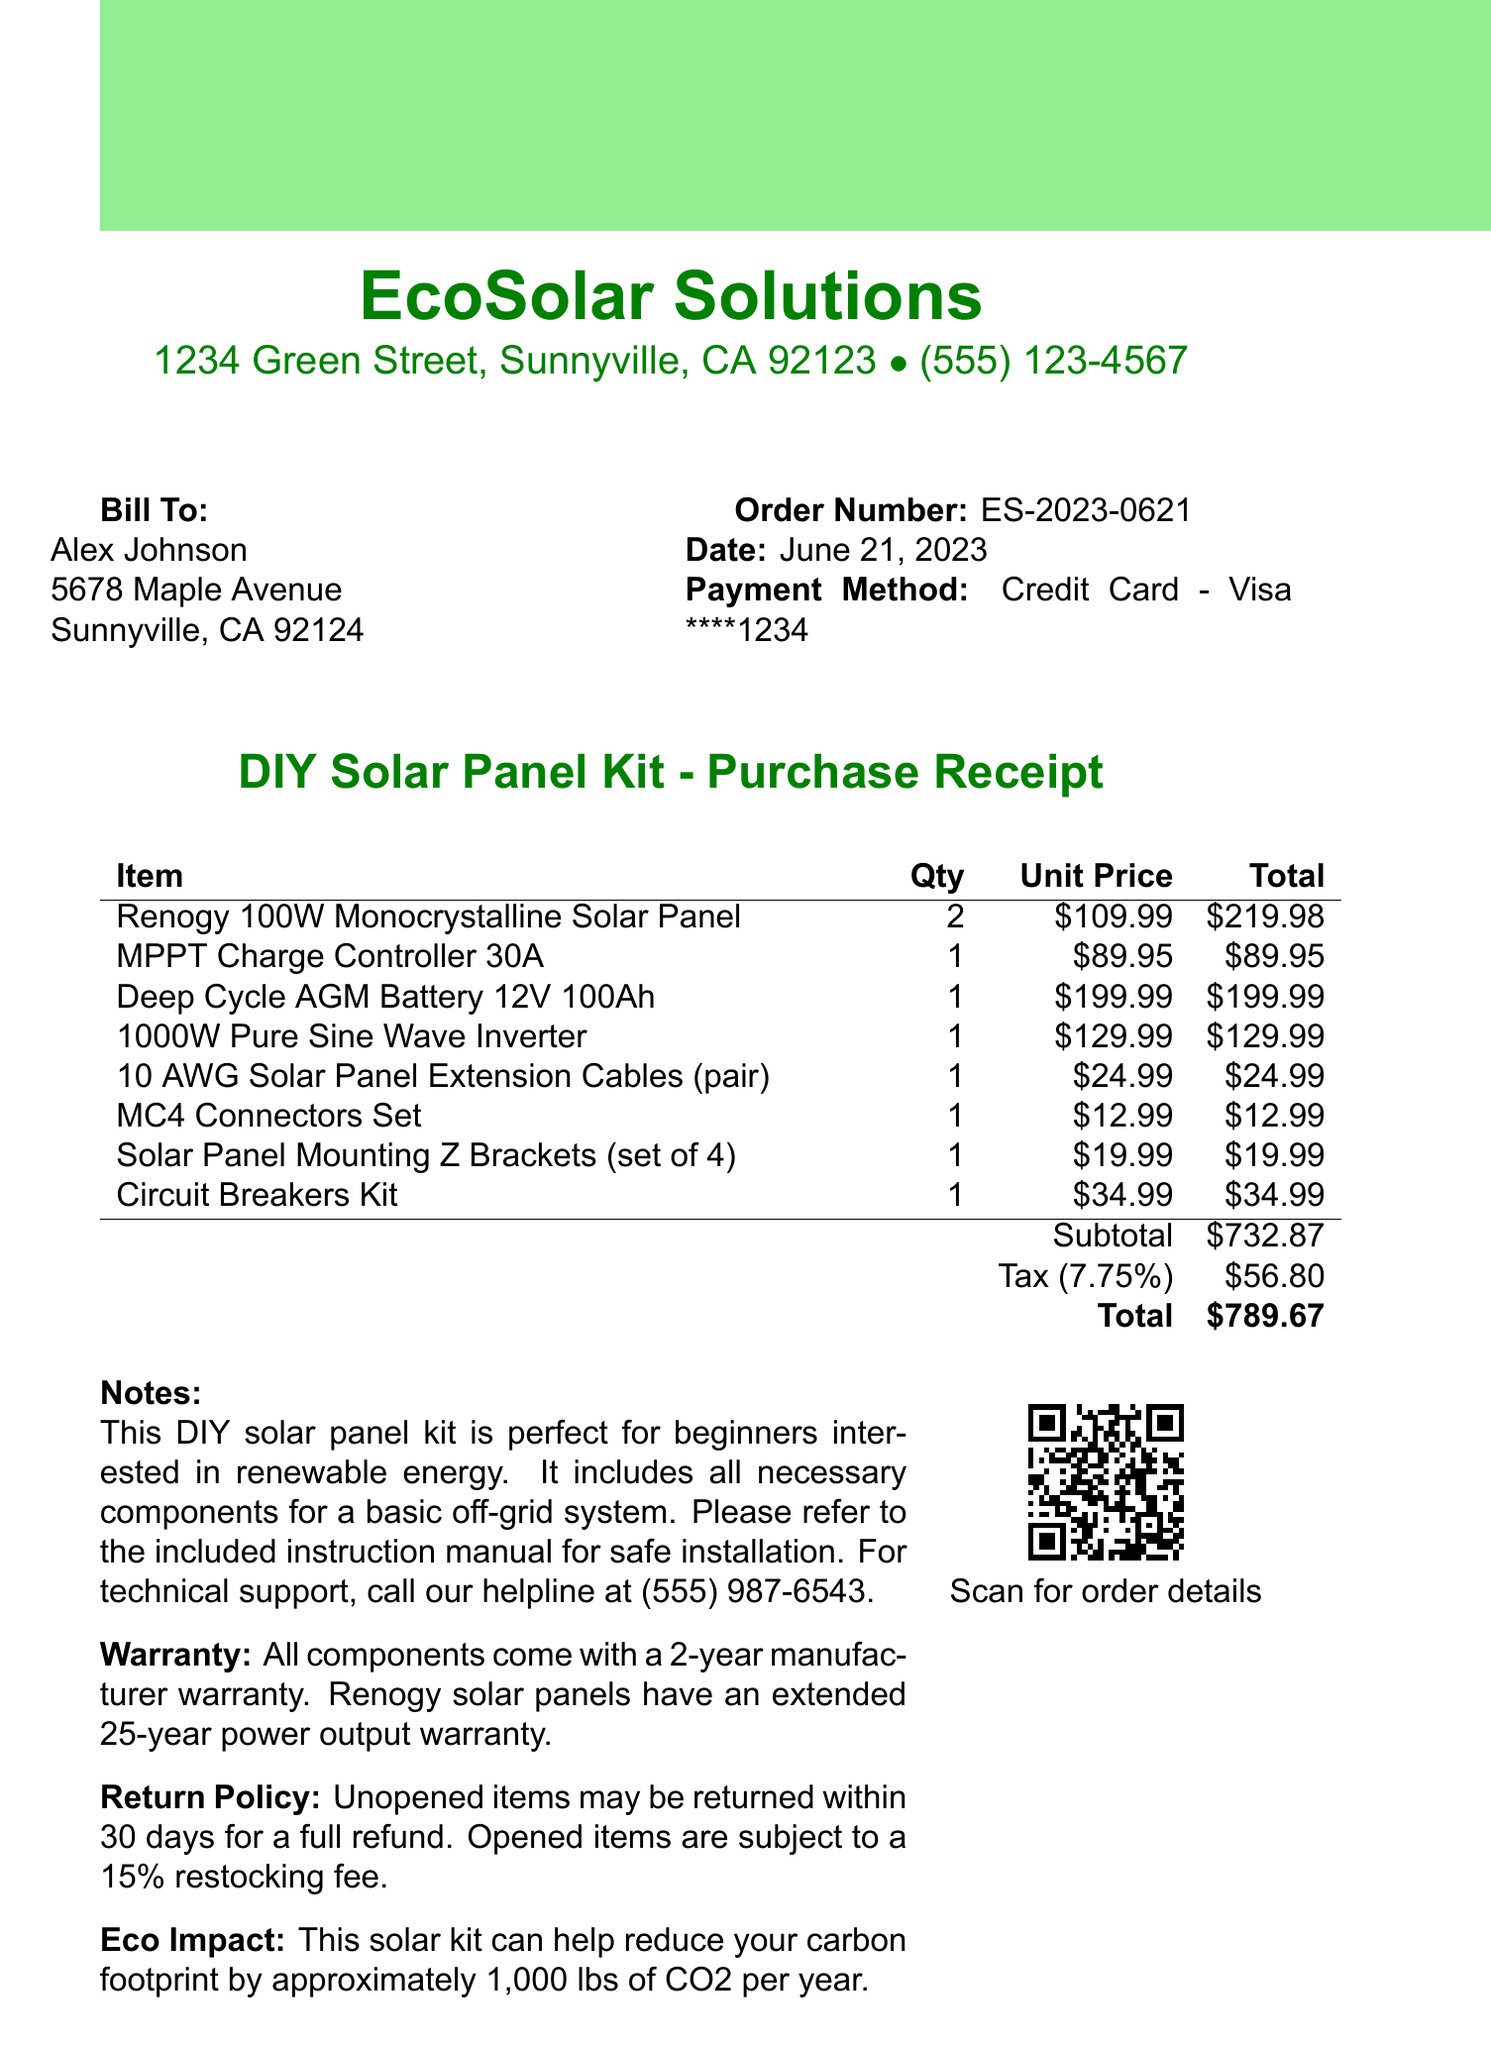What is the store name? The store name is clearly stated at the top of the document.
Answer: EcoSolar Solutions What is the date of the transaction? The date of the transaction is specified in the document next to the order number.
Answer: June 21, 2023 How many solar panels were purchased? The quantity of solar panels is listed in the itemized section for the Renogy solar panel.
Answer: 2 What is the total cost of the purchase? The total cost is provided in the summary section of the invoice.
Answer: $789.67 What is the warranty period for the components? The warranty information is included in the notes section of the document.
Answer: 2 years What is the tax rate applied? The tax rate is noted in the summary of costs in the document.
Answer: 7.75% How many items are in the DIY solar panel kit? The document lists individual components, which can be counted for the total.
Answer: 8 What is the eco impact mentioned? The eco impact is described in the summary notes of the document.
Answer: 1,000 lbs of CO2 per year What payment method was used? The payment method is specified as part of the transaction details.
Answer: Credit Card - Visa ****1234 